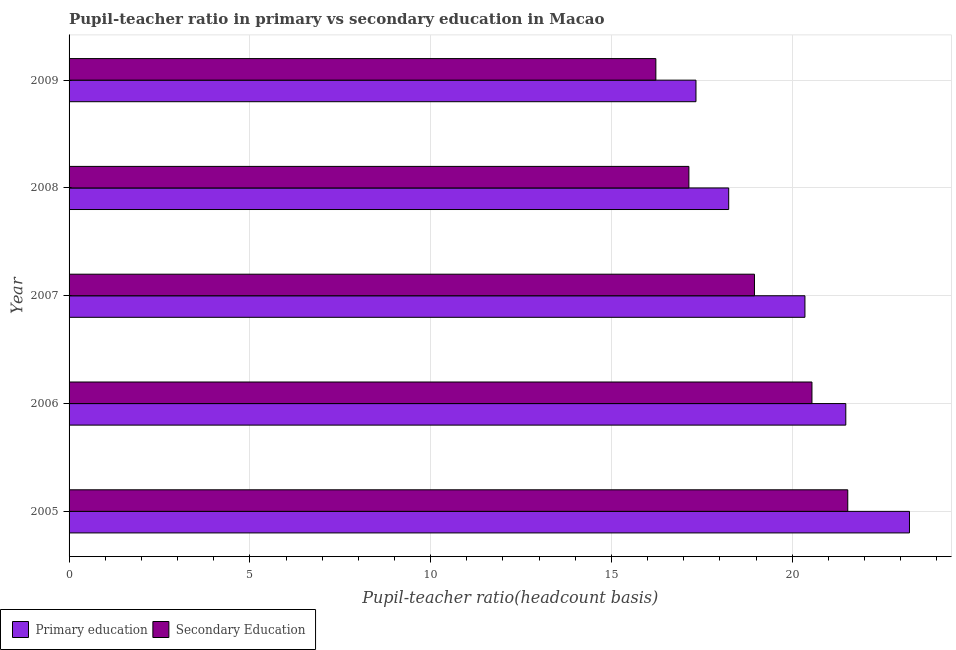How many groups of bars are there?
Your response must be concise. 5. Are the number of bars per tick equal to the number of legend labels?
Keep it short and to the point. Yes. Are the number of bars on each tick of the Y-axis equal?
Offer a very short reply. Yes. How many bars are there on the 1st tick from the top?
Provide a short and direct response. 2. How many bars are there on the 2nd tick from the bottom?
Keep it short and to the point. 2. In how many cases, is the number of bars for a given year not equal to the number of legend labels?
Ensure brevity in your answer.  0. What is the pupil teacher ratio on secondary education in 2006?
Provide a succinct answer. 20.55. Across all years, what is the maximum pupil-teacher ratio in primary education?
Make the answer very short. 23.24. Across all years, what is the minimum pupil teacher ratio on secondary education?
Your answer should be compact. 16.23. What is the total pupil teacher ratio on secondary education in the graph?
Your response must be concise. 94.42. What is the difference between the pupil-teacher ratio in primary education in 2006 and that in 2008?
Ensure brevity in your answer.  3.24. What is the difference between the pupil-teacher ratio in primary education in 2009 and the pupil teacher ratio on secondary education in 2007?
Make the answer very short. -1.62. What is the average pupil-teacher ratio in primary education per year?
Give a very brief answer. 20.13. In the year 2009, what is the difference between the pupil teacher ratio on secondary education and pupil-teacher ratio in primary education?
Your response must be concise. -1.11. What is the ratio of the pupil teacher ratio on secondary education in 2008 to that in 2009?
Keep it short and to the point. 1.06. Is the difference between the pupil teacher ratio on secondary education in 2005 and 2006 greater than the difference between the pupil-teacher ratio in primary education in 2005 and 2006?
Your answer should be very brief. No. What is the difference between the highest and the second highest pupil-teacher ratio in primary education?
Offer a terse response. 1.76. What is the difference between the highest and the lowest pupil teacher ratio on secondary education?
Offer a terse response. 5.31. Is the sum of the pupil-teacher ratio in primary education in 2005 and 2009 greater than the maximum pupil teacher ratio on secondary education across all years?
Your response must be concise. Yes. How many bars are there?
Provide a short and direct response. 10. What is the difference between two consecutive major ticks on the X-axis?
Provide a succinct answer. 5. Does the graph contain any zero values?
Give a very brief answer. No. What is the title of the graph?
Provide a short and direct response. Pupil-teacher ratio in primary vs secondary education in Macao. What is the label or title of the X-axis?
Keep it short and to the point. Pupil-teacher ratio(headcount basis). What is the label or title of the Y-axis?
Your response must be concise. Year. What is the Pupil-teacher ratio(headcount basis) in Primary education in 2005?
Provide a succinct answer. 23.24. What is the Pupil-teacher ratio(headcount basis) of Secondary Education in 2005?
Your response must be concise. 21.54. What is the Pupil-teacher ratio(headcount basis) in Primary education in 2006?
Provide a short and direct response. 21.48. What is the Pupil-teacher ratio(headcount basis) of Secondary Education in 2006?
Make the answer very short. 20.55. What is the Pupil-teacher ratio(headcount basis) in Primary education in 2007?
Your answer should be very brief. 20.35. What is the Pupil-teacher ratio(headcount basis) of Secondary Education in 2007?
Make the answer very short. 18.96. What is the Pupil-teacher ratio(headcount basis) in Primary education in 2008?
Provide a short and direct response. 18.24. What is the Pupil-teacher ratio(headcount basis) in Secondary Education in 2008?
Offer a terse response. 17.14. What is the Pupil-teacher ratio(headcount basis) in Primary education in 2009?
Offer a very short reply. 17.34. What is the Pupil-teacher ratio(headcount basis) of Secondary Education in 2009?
Your answer should be compact. 16.23. Across all years, what is the maximum Pupil-teacher ratio(headcount basis) in Primary education?
Your answer should be very brief. 23.24. Across all years, what is the maximum Pupil-teacher ratio(headcount basis) of Secondary Education?
Your answer should be very brief. 21.54. Across all years, what is the minimum Pupil-teacher ratio(headcount basis) in Primary education?
Provide a succinct answer. 17.34. Across all years, what is the minimum Pupil-teacher ratio(headcount basis) of Secondary Education?
Provide a short and direct response. 16.23. What is the total Pupil-teacher ratio(headcount basis) in Primary education in the graph?
Give a very brief answer. 100.67. What is the total Pupil-teacher ratio(headcount basis) of Secondary Education in the graph?
Offer a very short reply. 94.42. What is the difference between the Pupil-teacher ratio(headcount basis) in Primary education in 2005 and that in 2006?
Give a very brief answer. 1.76. What is the difference between the Pupil-teacher ratio(headcount basis) of Secondary Education in 2005 and that in 2006?
Make the answer very short. 0.99. What is the difference between the Pupil-teacher ratio(headcount basis) in Primary education in 2005 and that in 2007?
Offer a very short reply. 2.89. What is the difference between the Pupil-teacher ratio(headcount basis) in Secondary Education in 2005 and that in 2007?
Provide a short and direct response. 2.58. What is the difference between the Pupil-teacher ratio(headcount basis) in Primary education in 2005 and that in 2008?
Your response must be concise. 5. What is the difference between the Pupil-teacher ratio(headcount basis) in Secondary Education in 2005 and that in 2008?
Your answer should be very brief. 4.39. What is the difference between the Pupil-teacher ratio(headcount basis) in Primary education in 2005 and that in 2009?
Provide a succinct answer. 5.91. What is the difference between the Pupil-teacher ratio(headcount basis) in Secondary Education in 2005 and that in 2009?
Keep it short and to the point. 5.31. What is the difference between the Pupil-teacher ratio(headcount basis) of Primary education in 2006 and that in 2007?
Make the answer very short. 1.13. What is the difference between the Pupil-teacher ratio(headcount basis) of Secondary Education in 2006 and that in 2007?
Give a very brief answer. 1.59. What is the difference between the Pupil-teacher ratio(headcount basis) in Primary education in 2006 and that in 2008?
Your answer should be compact. 3.24. What is the difference between the Pupil-teacher ratio(headcount basis) of Secondary Education in 2006 and that in 2008?
Offer a terse response. 3.4. What is the difference between the Pupil-teacher ratio(headcount basis) in Primary education in 2006 and that in 2009?
Offer a very short reply. 4.14. What is the difference between the Pupil-teacher ratio(headcount basis) of Secondary Education in 2006 and that in 2009?
Keep it short and to the point. 4.32. What is the difference between the Pupil-teacher ratio(headcount basis) of Primary education in 2007 and that in 2008?
Offer a terse response. 2.11. What is the difference between the Pupil-teacher ratio(headcount basis) of Secondary Education in 2007 and that in 2008?
Offer a terse response. 1.81. What is the difference between the Pupil-teacher ratio(headcount basis) of Primary education in 2007 and that in 2009?
Keep it short and to the point. 3.01. What is the difference between the Pupil-teacher ratio(headcount basis) of Secondary Education in 2007 and that in 2009?
Keep it short and to the point. 2.73. What is the difference between the Pupil-teacher ratio(headcount basis) of Primary education in 2008 and that in 2009?
Offer a very short reply. 0.91. What is the difference between the Pupil-teacher ratio(headcount basis) in Secondary Education in 2008 and that in 2009?
Your answer should be compact. 0.91. What is the difference between the Pupil-teacher ratio(headcount basis) of Primary education in 2005 and the Pupil-teacher ratio(headcount basis) of Secondary Education in 2006?
Offer a very short reply. 2.7. What is the difference between the Pupil-teacher ratio(headcount basis) in Primary education in 2005 and the Pupil-teacher ratio(headcount basis) in Secondary Education in 2007?
Your response must be concise. 4.29. What is the difference between the Pupil-teacher ratio(headcount basis) of Primary education in 2005 and the Pupil-teacher ratio(headcount basis) of Secondary Education in 2008?
Keep it short and to the point. 6.1. What is the difference between the Pupil-teacher ratio(headcount basis) in Primary education in 2005 and the Pupil-teacher ratio(headcount basis) in Secondary Education in 2009?
Keep it short and to the point. 7.01. What is the difference between the Pupil-teacher ratio(headcount basis) in Primary education in 2006 and the Pupil-teacher ratio(headcount basis) in Secondary Education in 2007?
Keep it short and to the point. 2.53. What is the difference between the Pupil-teacher ratio(headcount basis) in Primary education in 2006 and the Pupil-teacher ratio(headcount basis) in Secondary Education in 2008?
Provide a short and direct response. 4.34. What is the difference between the Pupil-teacher ratio(headcount basis) of Primary education in 2006 and the Pupil-teacher ratio(headcount basis) of Secondary Education in 2009?
Offer a terse response. 5.25. What is the difference between the Pupil-teacher ratio(headcount basis) in Primary education in 2007 and the Pupil-teacher ratio(headcount basis) in Secondary Education in 2008?
Provide a succinct answer. 3.21. What is the difference between the Pupil-teacher ratio(headcount basis) in Primary education in 2007 and the Pupil-teacher ratio(headcount basis) in Secondary Education in 2009?
Offer a terse response. 4.12. What is the difference between the Pupil-teacher ratio(headcount basis) of Primary education in 2008 and the Pupil-teacher ratio(headcount basis) of Secondary Education in 2009?
Give a very brief answer. 2.01. What is the average Pupil-teacher ratio(headcount basis) in Primary education per year?
Offer a very short reply. 20.13. What is the average Pupil-teacher ratio(headcount basis) of Secondary Education per year?
Provide a short and direct response. 18.88. In the year 2005, what is the difference between the Pupil-teacher ratio(headcount basis) in Primary education and Pupil-teacher ratio(headcount basis) in Secondary Education?
Your response must be concise. 1.71. In the year 2006, what is the difference between the Pupil-teacher ratio(headcount basis) in Primary education and Pupil-teacher ratio(headcount basis) in Secondary Education?
Offer a terse response. 0.94. In the year 2007, what is the difference between the Pupil-teacher ratio(headcount basis) in Primary education and Pupil-teacher ratio(headcount basis) in Secondary Education?
Ensure brevity in your answer.  1.4. In the year 2008, what is the difference between the Pupil-teacher ratio(headcount basis) of Primary education and Pupil-teacher ratio(headcount basis) of Secondary Education?
Ensure brevity in your answer.  1.1. In the year 2009, what is the difference between the Pupil-teacher ratio(headcount basis) in Primary education and Pupil-teacher ratio(headcount basis) in Secondary Education?
Provide a short and direct response. 1.11. What is the ratio of the Pupil-teacher ratio(headcount basis) of Primary education in 2005 to that in 2006?
Ensure brevity in your answer.  1.08. What is the ratio of the Pupil-teacher ratio(headcount basis) of Secondary Education in 2005 to that in 2006?
Provide a succinct answer. 1.05. What is the ratio of the Pupil-teacher ratio(headcount basis) in Primary education in 2005 to that in 2007?
Keep it short and to the point. 1.14. What is the ratio of the Pupil-teacher ratio(headcount basis) of Secondary Education in 2005 to that in 2007?
Your answer should be very brief. 1.14. What is the ratio of the Pupil-teacher ratio(headcount basis) of Primary education in 2005 to that in 2008?
Make the answer very short. 1.27. What is the ratio of the Pupil-teacher ratio(headcount basis) in Secondary Education in 2005 to that in 2008?
Provide a succinct answer. 1.26. What is the ratio of the Pupil-teacher ratio(headcount basis) of Primary education in 2005 to that in 2009?
Offer a terse response. 1.34. What is the ratio of the Pupil-teacher ratio(headcount basis) in Secondary Education in 2005 to that in 2009?
Offer a terse response. 1.33. What is the ratio of the Pupil-teacher ratio(headcount basis) in Primary education in 2006 to that in 2007?
Provide a short and direct response. 1.06. What is the ratio of the Pupil-teacher ratio(headcount basis) in Secondary Education in 2006 to that in 2007?
Make the answer very short. 1.08. What is the ratio of the Pupil-teacher ratio(headcount basis) of Primary education in 2006 to that in 2008?
Your response must be concise. 1.18. What is the ratio of the Pupil-teacher ratio(headcount basis) in Secondary Education in 2006 to that in 2008?
Your answer should be compact. 1.2. What is the ratio of the Pupil-teacher ratio(headcount basis) in Primary education in 2006 to that in 2009?
Offer a terse response. 1.24. What is the ratio of the Pupil-teacher ratio(headcount basis) of Secondary Education in 2006 to that in 2009?
Keep it short and to the point. 1.27. What is the ratio of the Pupil-teacher ratio(headcount basis) in Primary education in 2007 to that in 2008?
Your answer should be compact. 1.12. What is the ratio of the Pupil-teacher ratio(headcount basis) in Secondary Education in 2007 to that in 2008?
Offer a very short reply. 1.11. What is the ratio of the Pupil-teacher ratio(headcount basis) of Primary education in 2007 to that in 2009?
Provide a short and direct response. 1.17. What is the ratio of the Pupil-teacher ratio(headcount basis) of Secondary Education in 2007 to that in 2009?
Your answer should be compact. 1.17. What is the ratio of the Pupil-teacher ratio(headcount basis) of Primary education in 2008 to that in 2009?
Keep it short and to the point. 1.05. What is the ratio of the Pupil-teacher ratio(headcount basis) of Secondary Education in 2008 to that in 2009?
Make the answer very short. 1.06. What is the difference between the highest and the second highest Pupil-teacher ratio(headcount basis) in Primary education?
Give a very brief answer. 1.76. What is the difference between the highest and the second highest Pupil-teacher ratio(headcount basis) of Secondary Education?
Ensure brevity in your answer.  0.99. What is the difference between the highest and the lowest Pupil-teacher ratio(headcount basis) of Primary education?
Your answer should be very brief. 5.91. What is the difference between the highest and the lowest Pupil-teacher ratio(headcount basis) in Secondary Education?
Provide a succinct answer. 5.31. 